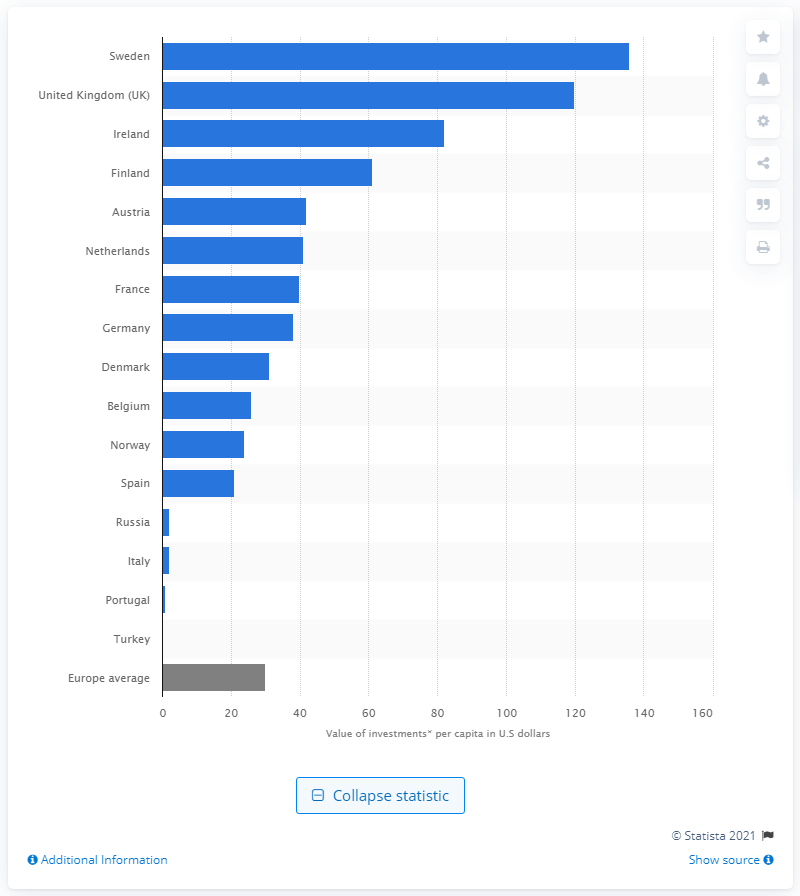Specify some key components in this picture. In 2017, the highest amount of venture capital investment per capita was recorded in Sweden, at 136. 